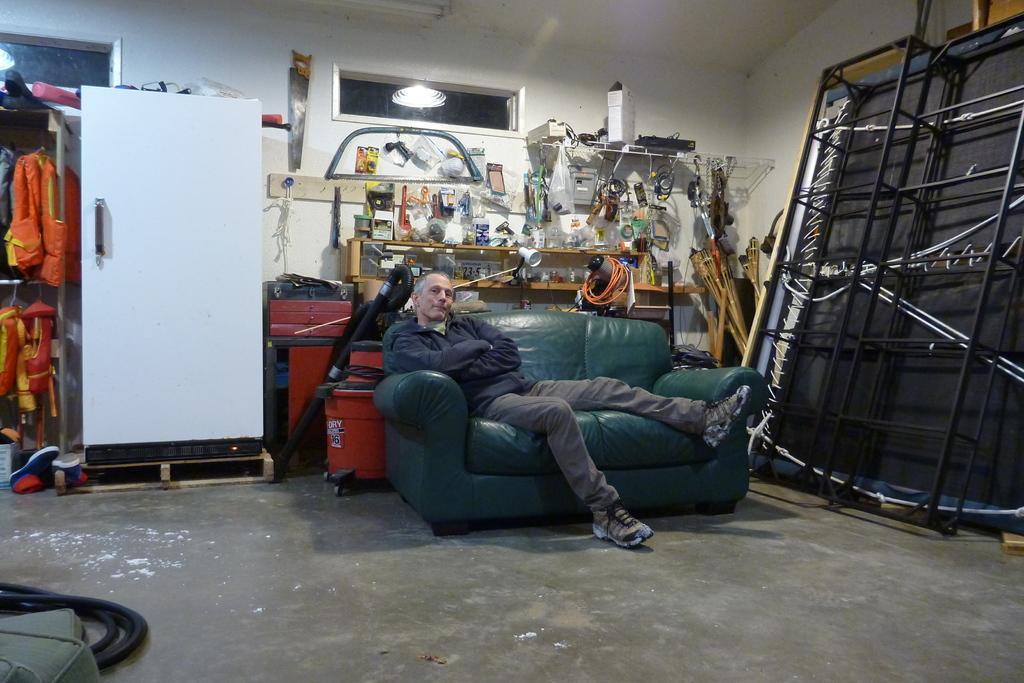Can you describe this image briefly? This image is taken indoors. At the bottom of the image there is a floor. In the background there is a wall with two ventilators. At the top of the image there is a roof. In the middle of the image a man is sitting on the couch. There are many things on the floor and there are a few things on the shelves. On the left side of the image there is a wardrobe and there are a few safety jackets on the shelves. There are two shoes and there is a pipe on the floor. On the right side of the image there is a wooden board and there are a few iron bars. 